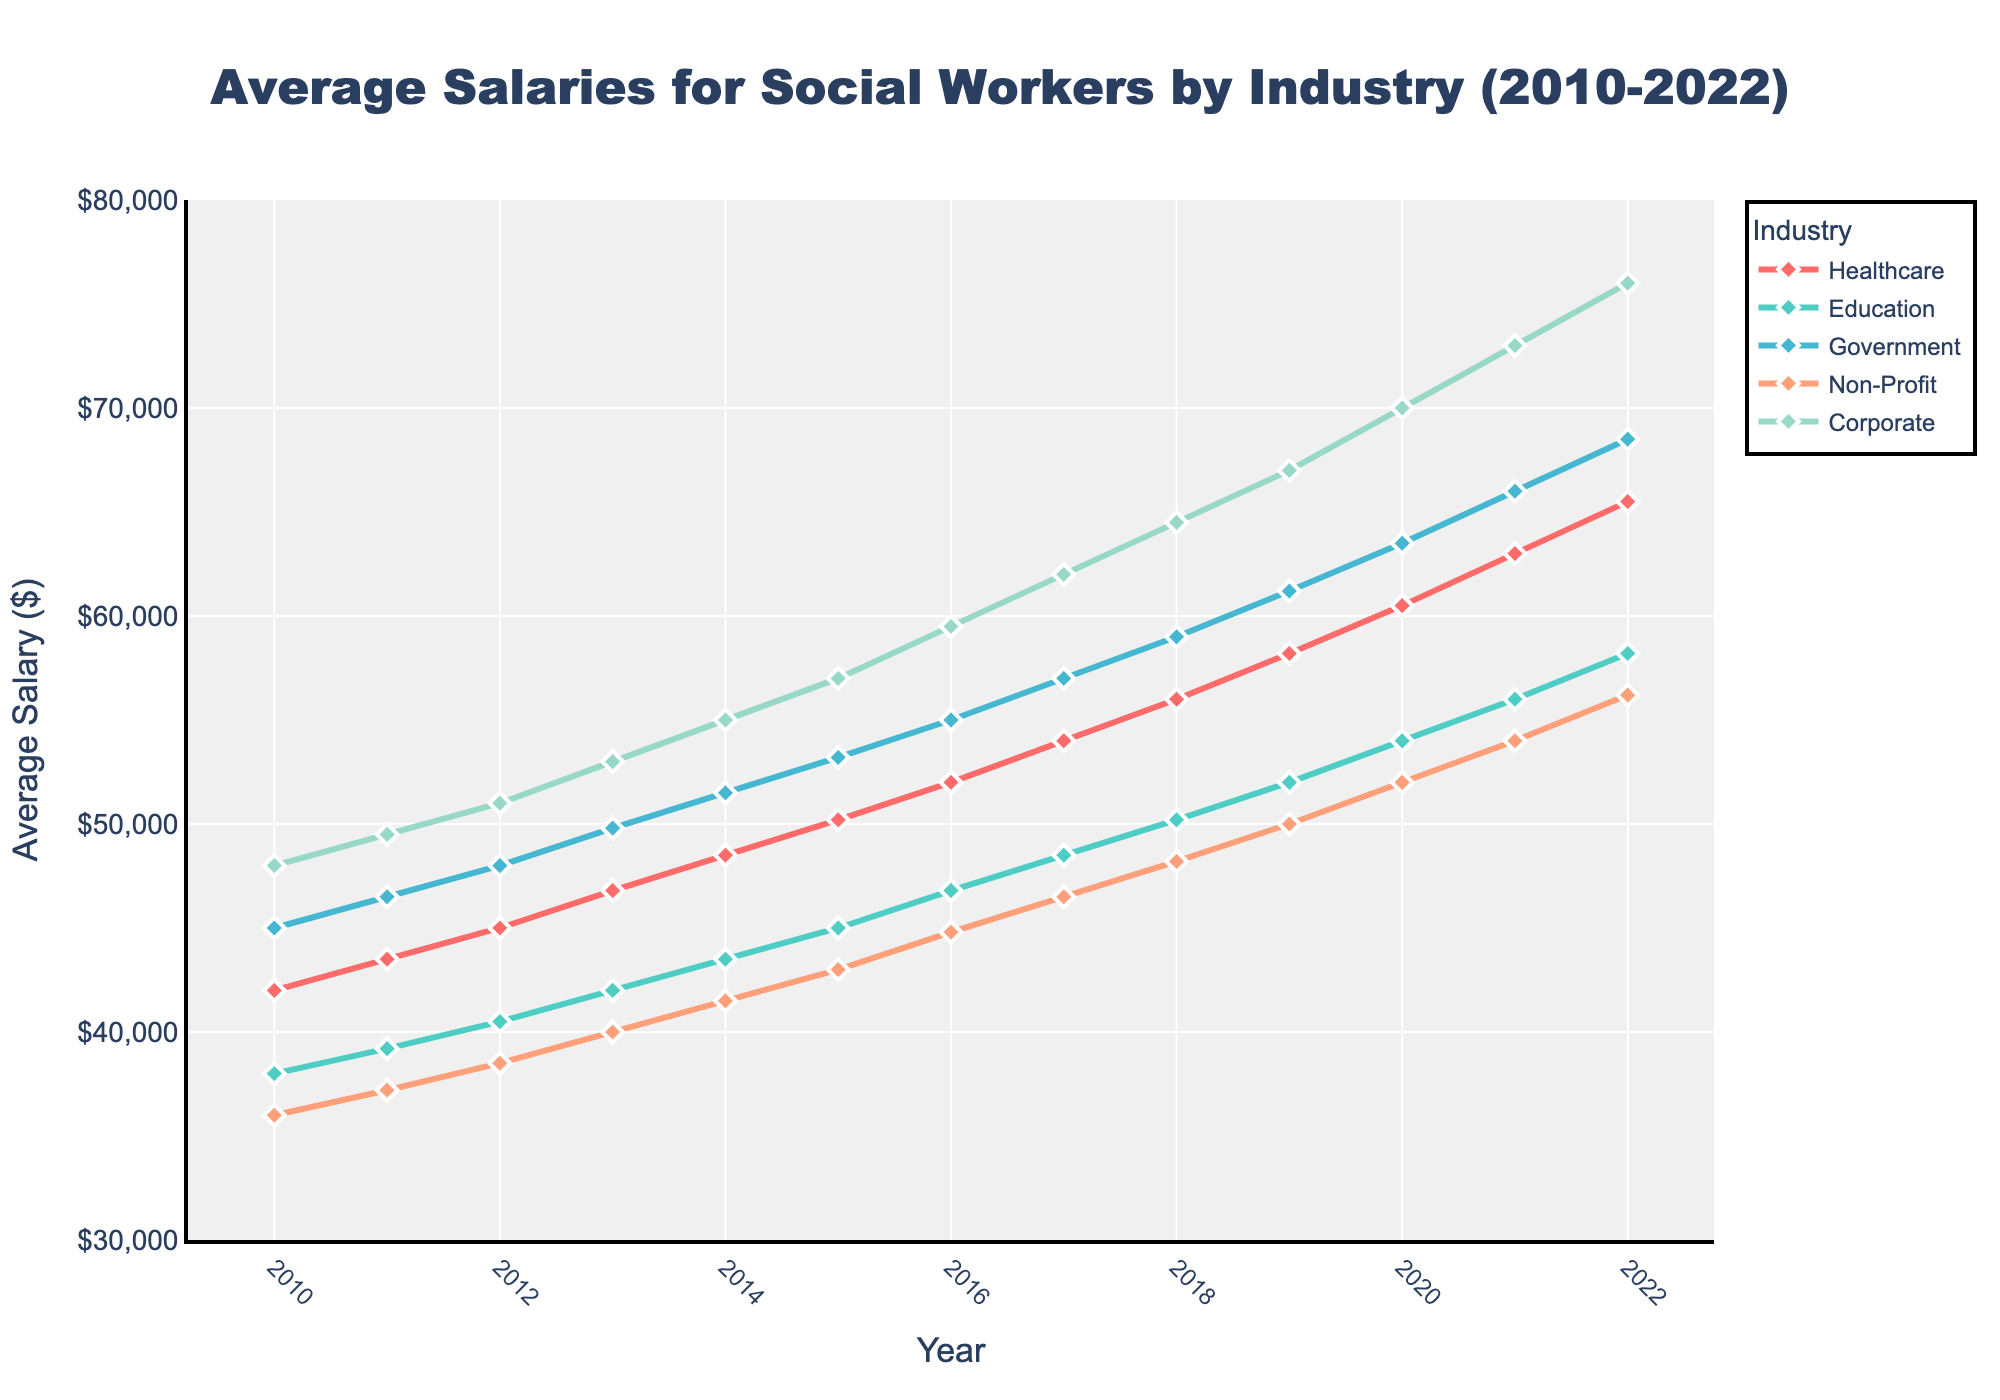What was the average salary of social workers in the Government industry in 2014? Locate the Government line on the chart and find the value corresponding to the year 2014, which is around $51,500
Answer: $51,500 In which year did the Healthcare industry's average salary surpass $50,000? Follow the trend line for the Healthcare industry and identify the first year where the value exceeds $50,000, which is 2015
Answer: 2015 Which industry had the highest average salary in 2022? Look at the end of the chart for the year 2022 and compare values for all industries; the Corporate industry shows the highest value at $76,000
Answer: Corporate How much did the average salary for social workers in the Education industry increase from 2010 to 2022? Find the Education values for 2010 and 2022, which are $38,000 and $58,200, then subtract the former from the latter: $58,200 - $38,000 = $20,200
Answer: $20,200 By how much did the average salary for social workers in the Non-Profit industry increase from 2016 to 2018? Find the Non-Profit values for 2016 and 2018, which are $44,800 and $48,200, then subtract the former from the latter: $48,200 - $44,800 = $3,400
Answer: $3,400 Which two industries had the smallest difference in average salaries in 2020, and what was the difference? Compare the 2020 values for all pairs of industries and find the smallest difference. The smallest difference is between Healthcare ($60,500) and Government ($63,500): $63,500 - $60,500 = $3,000
Answer: Healthcare and Government, $3,000 Did the Education industry's average salary ever exceed that of the Non-Profit industry between 2010 and 2022? Compare the Education and Non-Profit lines over the entire period; observe that the Education line is consistently above the Non-Profit line from 2010 to 2022
Answer: Yes In which year was the gap between the highest and lowest average salaries for social workers the largest, and what was the difference? Identify the largest gap by comparing the highest and lowest values each year; the largest difference is in 2022 between Corporate ($76,000) and Non-Profit ($56,200): $76,000 - $56,200 = $19,800
Answer: 2022, $19,800 Between which two consecutive years did the Corporate industry's average salary increase the most, and by how much? Look for the largest jump in the Corporate trend line between consecutive years; the largest increase is between 2011 ($49,500) and 2012 ($51,000): $51,000 - $49,500 = $1,500
Answer: 2011-2012, $1,500 